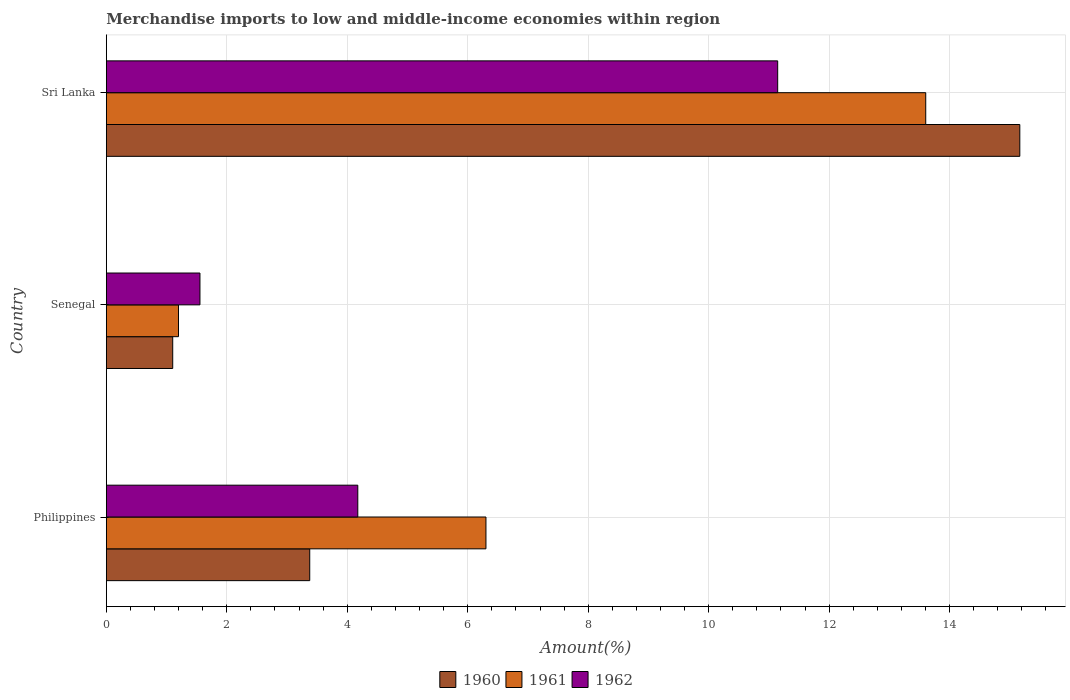How many different coloured bars are there?
Provide a succinct answer. 3. Are the number of bars per tick equal to the number of legend labels?
Your answer should be very brief. Yes. Are the number of bars on each tick of the Y-axis equal?
Provide a short and direct response. Yes. How many bars are there on the 2nd tick from the top?
Your answer should be compact. 3. How many bars are there on the 2nd tick from the bottom?
Provide a succinct answer. 3. What is the label of the 1st group of bars from the top?
Provide a short and direct response. Sri Lanka. What is the percentage of amount earned from merchandise imports in 1960 in Senegal?
Provide a short and direct response. 1.1. Across all countries, what is the maximum percentage of amount earned from merchandise imports in 1960?
Offer a terse response. 15.17. Across all countries, what is the minimum percentage of amount earned from merchandise imports in 1960?
Ensure brevity in your answer.  1.1. In which country was the percentage of amount earned from merchandise imports in 1960 maximum?
Your response must be concise. Sri Lanka. In which country was the percentage of amount earned from merchandise imports in 1962 minimum?
Make the answer very short. Senegal. What is the total percentage of amount earned from merchandise imports in 1962 in the graph?
Ensure brevity in your answer.  16.88. What is the difference between the percentage of amount earned from merchandise imports in 1961 in Philippines and that in Sri Lanka?
Provide a succinct answer. -7.3. What is the difference between the percentage of amount earned from merchandise imports in 1960 in Sri Lanka and the percentage of amount earned from merchandise imports in 1961 in Senegal?
Your answer should be compact. 13.97. What is the average percentage of amount earned from merchandise imports in 1960 per country?
Offer a terse response. 6.55. What is the difference between the percentage of amount earned from merchandise imports in 1962 and percentage of amount earned from merchandise imports in 1960 in Philippines?
Ensure brevity in your answer.  0.8. In how many countries, is the percentage of amount earned from merchandise imports in 1961 greater than 0.8 %?
Your response must be concise. 3. What is the ratio of the percentage of amount earned from merchandise imports in 1962 in Philippines to that in Senegal?
Make the answer very short. 2.69. Is the percentage of amount earned from merchandise imports in 1960 in Senegal less than that in Sri Lanka?
Your answer should be very brief. Yes. Is the difference between the percentage of amount earned from merchandise imports in 1962 in Philippines and Sri Lanka greater than the difference between the percentage of amount earned from merchandise imports in 1960 in Philippines and Sri Lanka?
Ensure brevity in your answer.  Yes. What is the difference between the highest and the second highest percentage of amount earned from merchandise imports in 1962?
Provide a short and direct response. 6.97. What is the difference between the highest and the lowest percentage of amount earned from merchandise imports in 1961?
Your answer should be very brief. 12.41. Are all the bars in the graph horizontal?
Your response must be concise. Yes. How many countries are there in the graph?
Your answer should be compact. 3. What is the difference between two consecutive major ticks on the X-axis?
Make the answer very short. 2. Does the graph contain any zero values?
Ensure brevity in your answer.  No. How many legend labels are there?
Give a very brief answer. 3. What is the title of the graph?
Your answer should be compact. Merchandise imports to low and middle-income economies within region. What is the label or title of the X-axis?
Your answer should be compact. Amount(%). What is the Amount(%) of 1960 in Philippines?
Offer a terse response. 3.38. What is the Amount(%) of 1961 in Philippines?
Give a very brief answer. 6.3. What is the Amount(%) in 1962 in Philippines?
Provide a short and direct response. 4.18. What is the Amount(%) of 1960 in Senegal?
Keep it short and to the point. 1.1. What is the Amount(%) in 1961 in Senegal?
Provide a succinct answer. 1.2. What is the Amount(%) of 1962 in Senegal?
Make the answer very short. 1.55. What is the Amount(%) in 1960 in Sri Lanka?
Your answer should be very brief. 15.17. What is the Amount(%) in 1961 in Sri Lanka?
Provide a short and direct response. 13.6. What is the Amount(%) of 1962 in Sri Lanka?
Your response must be concise. 11.15. Across all countries, what is the maximum Amount(%) of 1960?
Provide a short and direct response. 15.17. Across all countries, what is the maximum Amount(%) in 1961?
Ensure brevity in your answer.  13.6. Across all countries, what is the maximum Amount(%) in 1962?
Offer a terse response. 11.15. Across all countries, what is the minimum Amount(%) of 1960?
Keep it short and to the point. 1.1. Across all countries, what is the minimum Amount(%) in 1961?
Ensure brevity in your answer.  1.2. Across all countries, what is the minimum Amount(%) of 1962?
Your answer should be very brief. 1.55. What is the total Amount(%) of 1960 in the graph?
Make the answer very short. 19.65. What is the total Amount(%) of 1961 in the graph?
Keep it short and to the point. 21.11. What is the total Amount(%) in 1962 in the graph?
Your answer should be very brief. 16.88. What is the difference between the Amount(%) in 1960 in Philippines and that in Senegal?
Make the answer very short. 2.28. What is the difference between the Amount(%) of 1961 in Philippines and that in Senegal?
Keep it short and to the point. 5.1. What is the difference between the Amount(%) of 1962 in Philippines and that in Senegal?
Make the answer very short. 2.62. What is the difference between the Amount(%) in 1960 in Philippines and that in Sri Lanka?
Ensure brevity in your answer.  -11.79. What is the difference between the Amount(%) in 1961 in Philippines and that in Sri Lanka?
Give a very brief answer. -7.3. What is the difference between the Amount(%) in 1962 in Philippines and that in Sri Lanka?
Provide a short and direct response. -6.97. What is the difference between the Amount(%) in 1960 in Senegal and that in Sri Lanka?
Ensure brevity in your answer.  -14.06. What is the difference between the Amount(%) in 1961 in Senegal and that in Sri Lanka?
Ensure brevity in your answer.  -12.41. What is the difference between the Amount(%) of 1962 in Senegal and that in Sri Lanka?
Your answer should be compact. -9.59. What is the difference between the Amount(%) of 1960 in Philippines and the Amount(%) of 1961 in Senegal?
Provide a short and direct response. 2.18. What is the difference between the Amount(%) of 1960 in Philippines and the Amount(%) of 1962 in Senegal?
Your answer should be very brief. 1.82. What is the difference between the Amount(%) in 1961 in Philippines and the Amount(%) in 1962 in Senegal?
Your response must be concise. 4.75. What is the difference between the Amount(%) in 1960 in Philippines and the Amount(%) in 1961 in Sri Lanka?
Provide a short and direct response. -10.23. What is the difference between the Amount(%) of 1960 in Philippines and the Amount(%) of 1962 in Sri Lanka?
Your answer should be very brief. -7.77. What is the difference between the Amount(%) in 1961 in Philippines and the Amount(%) in 1962 in Sri Lanka?
Keep it short and to the point. -4.84. What is the difference between the Amount(%) of 1960 in Senegal and the Amount(%) of 1961 in Sri Lanka?
Your answer should be very brief. -12.5. What is the difference between the Amount(%) in 1960 in Senegal and the Amount(%) in 1962 in Sri Lanka?
Give a very brief answer. -10.04. What is the difference between the Amount(%) in 1961 in Senegal and the Amount(%) in 1962 in Sri Lanka?
Provide a short and direct response. -9.95. What is the average Amount(%) of 1960 per country?
Give a very brief answer. 6.55. What is the average Amount(%) in 1961 per country?
Ensure brevity in your answer.  7.04. What is the average Amount(%) of 1962 per country?
Give a very brief answer. 5.63. What is the difference between the Amount(%) in 1960 and Amount(%) in 1961 in Philippines?
Your response must be concise. -2.93. What is the difference between the Amount(%) of 1960 and Amount(%) of 1962 in Philippines?
Provide a short and direct response. -0.8. What is the difference between the Amount(%) in 1961 and Amount(%) in 1962 in Philippines?
Offer a terse response. 2.13. What is the difference between the Amount(%) in 1960 and Amount(%) in 1961 in Senegal?
Ensure brevity in your answer.  -0.1. What is the difference between the Amount(%) in 1960 and Amount(%) in 1962 in Senegal?
Offer a terse response. -0.45. What is the difference between the Amount(%) in 1961 and Amount(%) in 1962 in Senegal?
Make the answer very short. -0.36. What is the difference between the Amount(%) of 1960 and Amount(%) of 1961 in Sri Lanka?
Keep it short and to the point. 1.56. What is the difference between the Amount(%) in 1960 and Amount(%) in 1962 in Sri Lanka?
Give a very brief answer. 4.02. What is the difference between the Amount(%) of 1961 and Amount(%) of 1962 in Sri Lanka?
Provide a succinct answer. 2.46. What is the ratio of the Amount(%) in 1960 in Philippines to that in Senegal?
Ensure brevity in your answer.  3.06. What is the ratio of the Amount(%) of 1961 in Philippines to that in Senegal?
Keep it short and to the point. 5.26. What is the ratio of the Amount(%) in 1962 in Philippines to that in Senegal?
Make the answer very short. 2.69. What is the ratio of the Amount(%) in 1960 in Philippines to that in Sri Lanka?
Give a very brief answer. 0.22. What is the ratio of the Amount(%) of 1961 in Philippines to that in Sri Lanka?
Give a very brief answer. 0.46. What is the ratio of the Amount(%) of 1962 in Philippines to that in Sri Lanka?
Make the answer very short. 0.37. What is the ratio of the Amount(%) of 1960 in Senegal to that in Sri Lanka?
Keep it short and to the point. 0.07. What is the ratio of the Amount(%) in 1961 in Senegal to that in Sri Lanka?
Provide a succinct answer. 0.09. What is the ratio of the Amount(%) of 1962 in Senegal to that in Sri Lanka?
Your response must be concise. 0.14. What is the difference between the highest and the second highest Amount(%) of 1960?
Provide a succinct answer. 11.79. What is the difference between the highest and the second highest Amount(%) in 1961?
Your answer should be compact. 7.3. What is the difference between the highest and the second highest Amount(%) in 1962?
Your answer should be compact. 6.97. What is the difference between the highest and the lowest Amount(%) of 1960?
Keep it short and to the point. 14.06. What is the difference between the highest and the lowest Amount(%) of 1961?
Offer a terse response. 12.41. What is the difference between the highest and the lowest Amount(%) of 1962?
Provide a succinct answer. 9.59. 